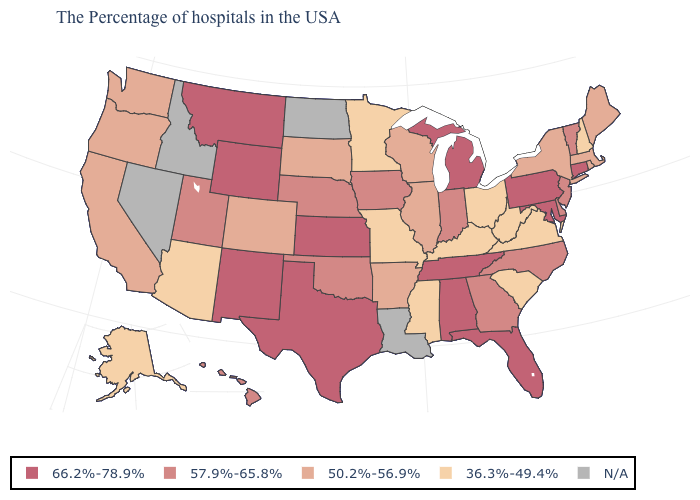How many symbols are there in the legend?
Answer briefly. 5. How many symbols are there in the legend?
Concise answer only. 5. What is the value of Idaho?
Keep it brief. N/A. What is the value of Ohio?
Short answer required. 36.3%-49.4%. Name the states that have a value in the range 66.2%-78.9%?
Concise answer only. Connecticut, Maryland, Pennsylvania, Florida, Michigan, Alabama, Tennessee, Kansas, Texas, Wyoming, New Mexico, Montana. What is the value of Oklahoma?
Short answer required. 57.9%-65.8%. What is the value of Minnesota?
Write a very short answer. 36.3%-49.4%. What is the value of Florida?
Quick response, please. 66.2%-78.9%. Does the map have missing data?
Write a very short answer. Yes. What is the value of Illinois?
Concise answer only. 50.2%-56.9%. Among the states that border Minnesota , which have the highest value?
Quick response, please. Iowa. Which states hav the highest value in the MidWest?
Keep it brief. Michigan, Kansas. Among the states that border Utah , which have the highest value?
Keep it brief. Wyoming, New Mexico. 